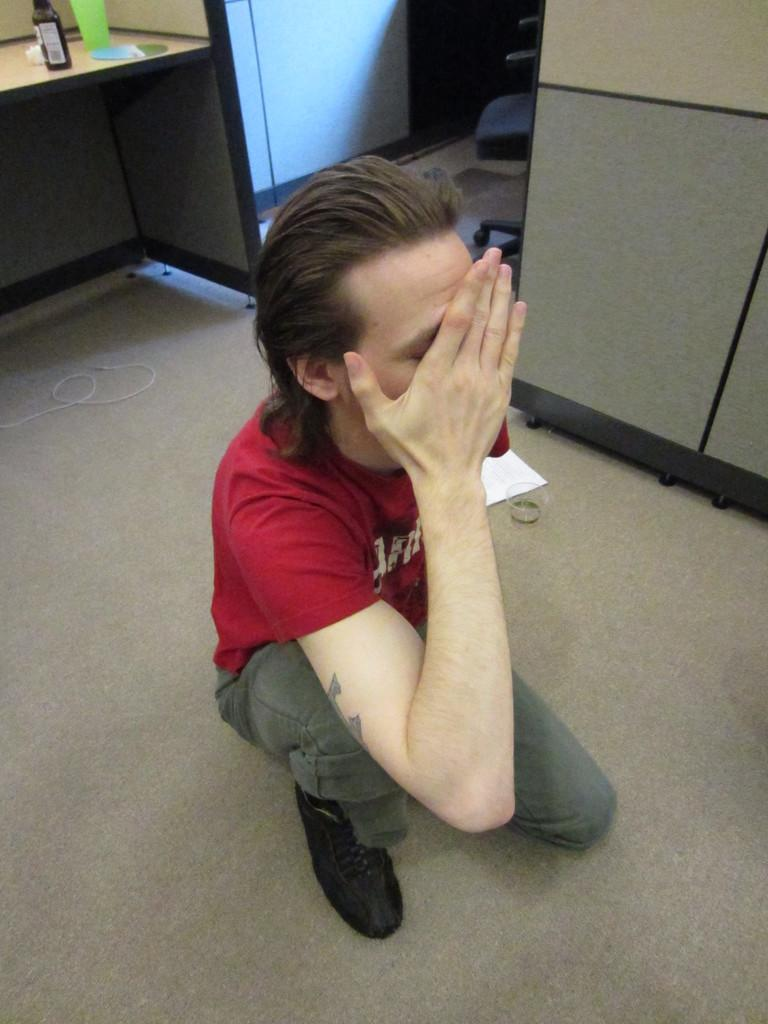What is the man in the image wearing? The man in the image is wearing a red t-shirt. What can be seen in the background of the image? There is a chair in the background of the image. What is on the table in the image? There are objects on a table in the image. What is present at the bottom of the image? There is a wire, a paper, and a glass on a mat at the bottom of the image. Can you tell me how many drawers are visible in the image? There are no drawers visible in the image. What type of frog can be seen sitting on the chair in the image? There is no frog present in the image; only a man, a chair, and other objects are visible. 